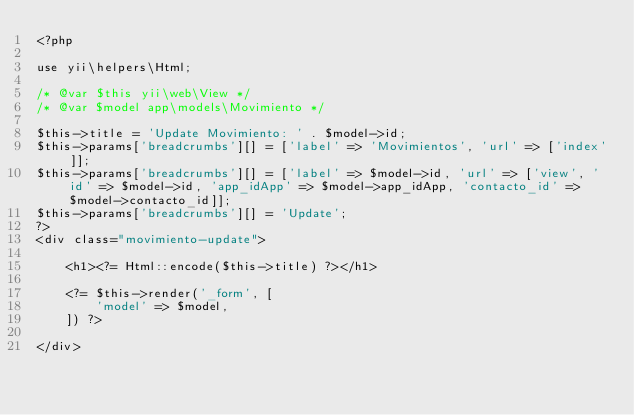Convert code to text. <code><loc_0><loc_0><loc_500><loc_500><_PHP_><?php

use yii\helpers\Html;

/* @var $this yii\web\View */
/* @var $model app\models\Movimiento */

$this->title = 'Update Movimiento: ' . $model->id;
$this->params['breadcrumbs'][] = ['label' => 'Movimientos', 'url' => ['index']];
$this->params['breadcrumbs'][] = ['label' => $model->id, 'url' => ['view', 'id' => $model->id, 'app_idApp' => $model->app_idApp, 'contacto_id' => $model->contacto_id]];
$this->params['breadcrumbs'][] = 'Update';
?>
<div class="movimiento-update">

    <h1><?= Html::encode($this->title) ?></h1>

    <?= $this->render('_form', [
        'model' => $model,
    ]) ?>

</div>
</code> 